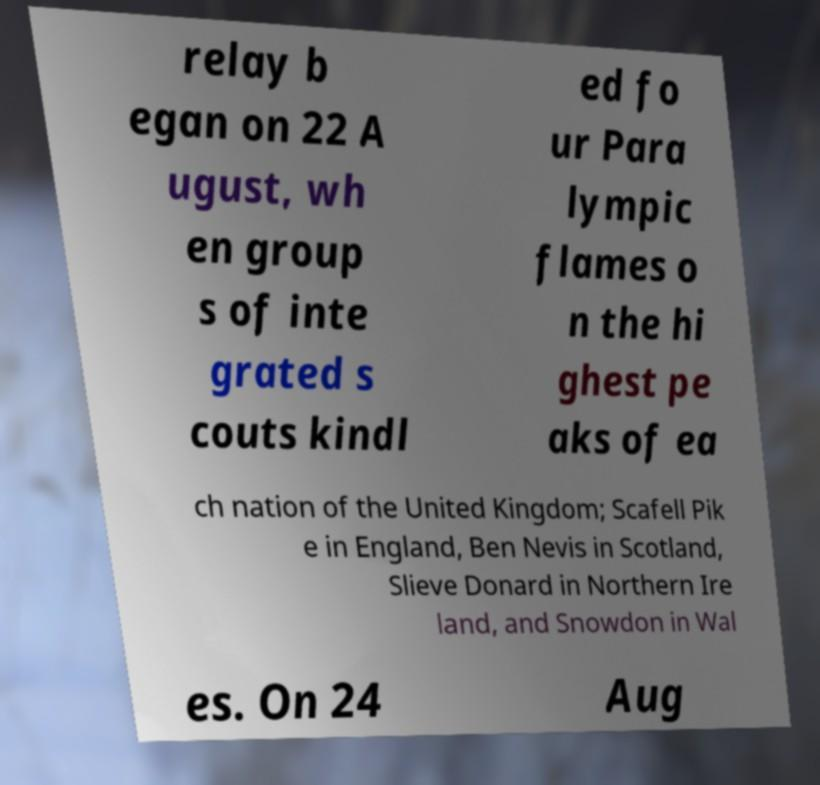I need the written content from this picture converted into text. Can you do that? relay b egan on 22 A ugust, wh en group s of inte grated s couts kindl ed fo ur Para lympic flames o n the hi ghest pe aks of ea ch nation of the United Kingdom; Scafell Pik e in England, Ben Nevis in Scotland, Slieve Donard in Northern Ire land, and Snowdon in Wal es. On 24 Aug 